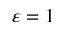Convert formula to latex. <formula><loc_0><loc_0><loc_500><loc_500>\varepsilon = 1</formula> 